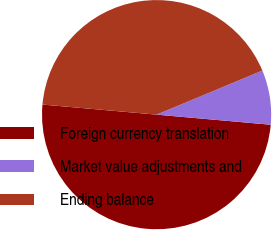Convert chart to OTSL. <chart><loc_0><loc_0><loc_500><loc_500><pie_chart><fcel>Foreign currency translation<fcel>Market value adjustments and<fcel>Ending balance<nl><fcel>50.0%<fcel>7.69%<fcel>42.31%<nl></chart> 